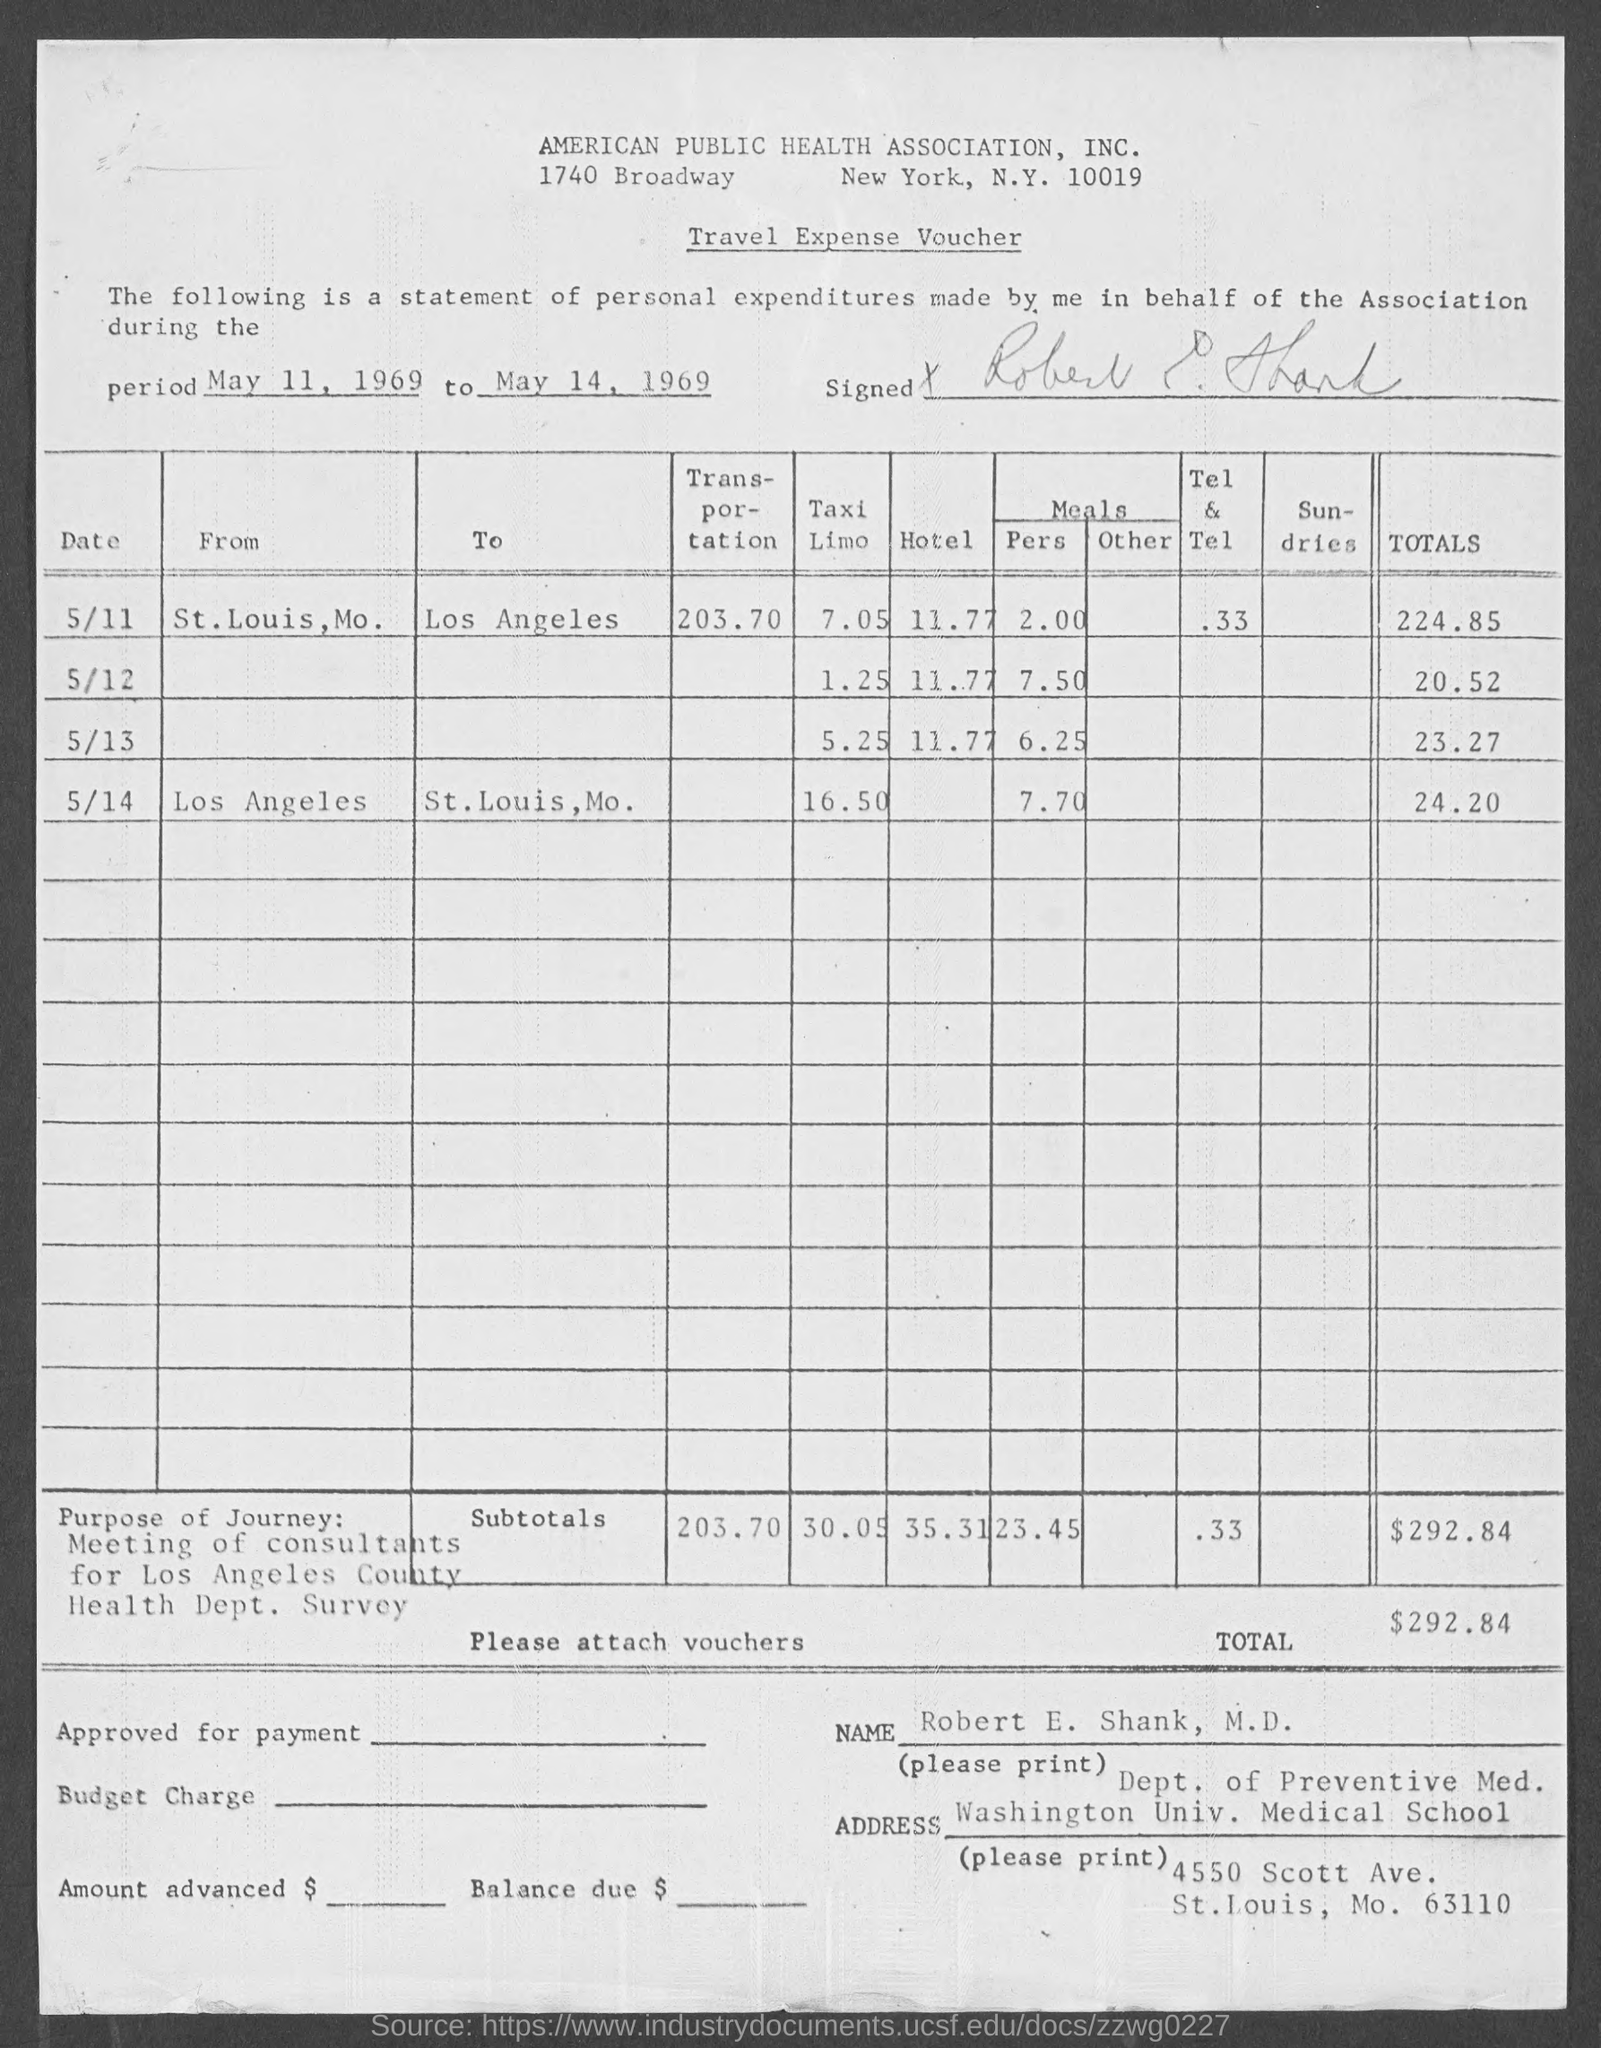Mention a couple of crucial points in this snapshot. The Travel Expense Voucher is the name of the voucher. The total amount is $292.84. Robert E. Shank, M.D. is a member of the Department of Preventive Medicine at the University of Minnesota, where he holds the position of Professor of Medicine and Pediatrics. 